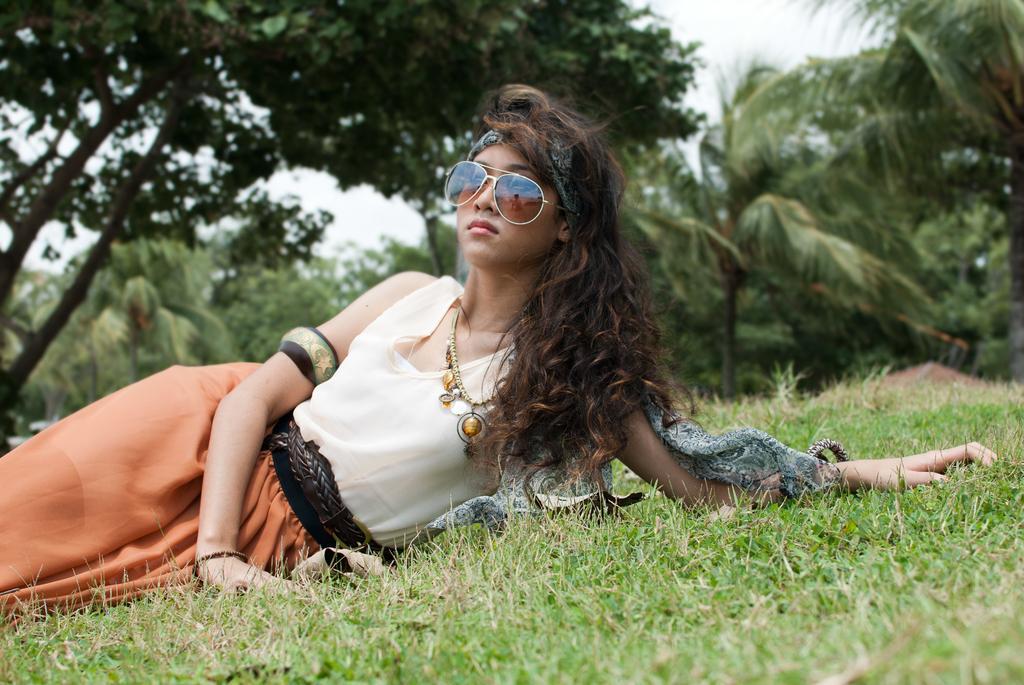In one or two sentences, can you explain what this image depicts? This image consists of a girl lying on the ground. At the bottom, there is grass. She is wearing shades. In the background, there are trees. To the top, there is a sky. 